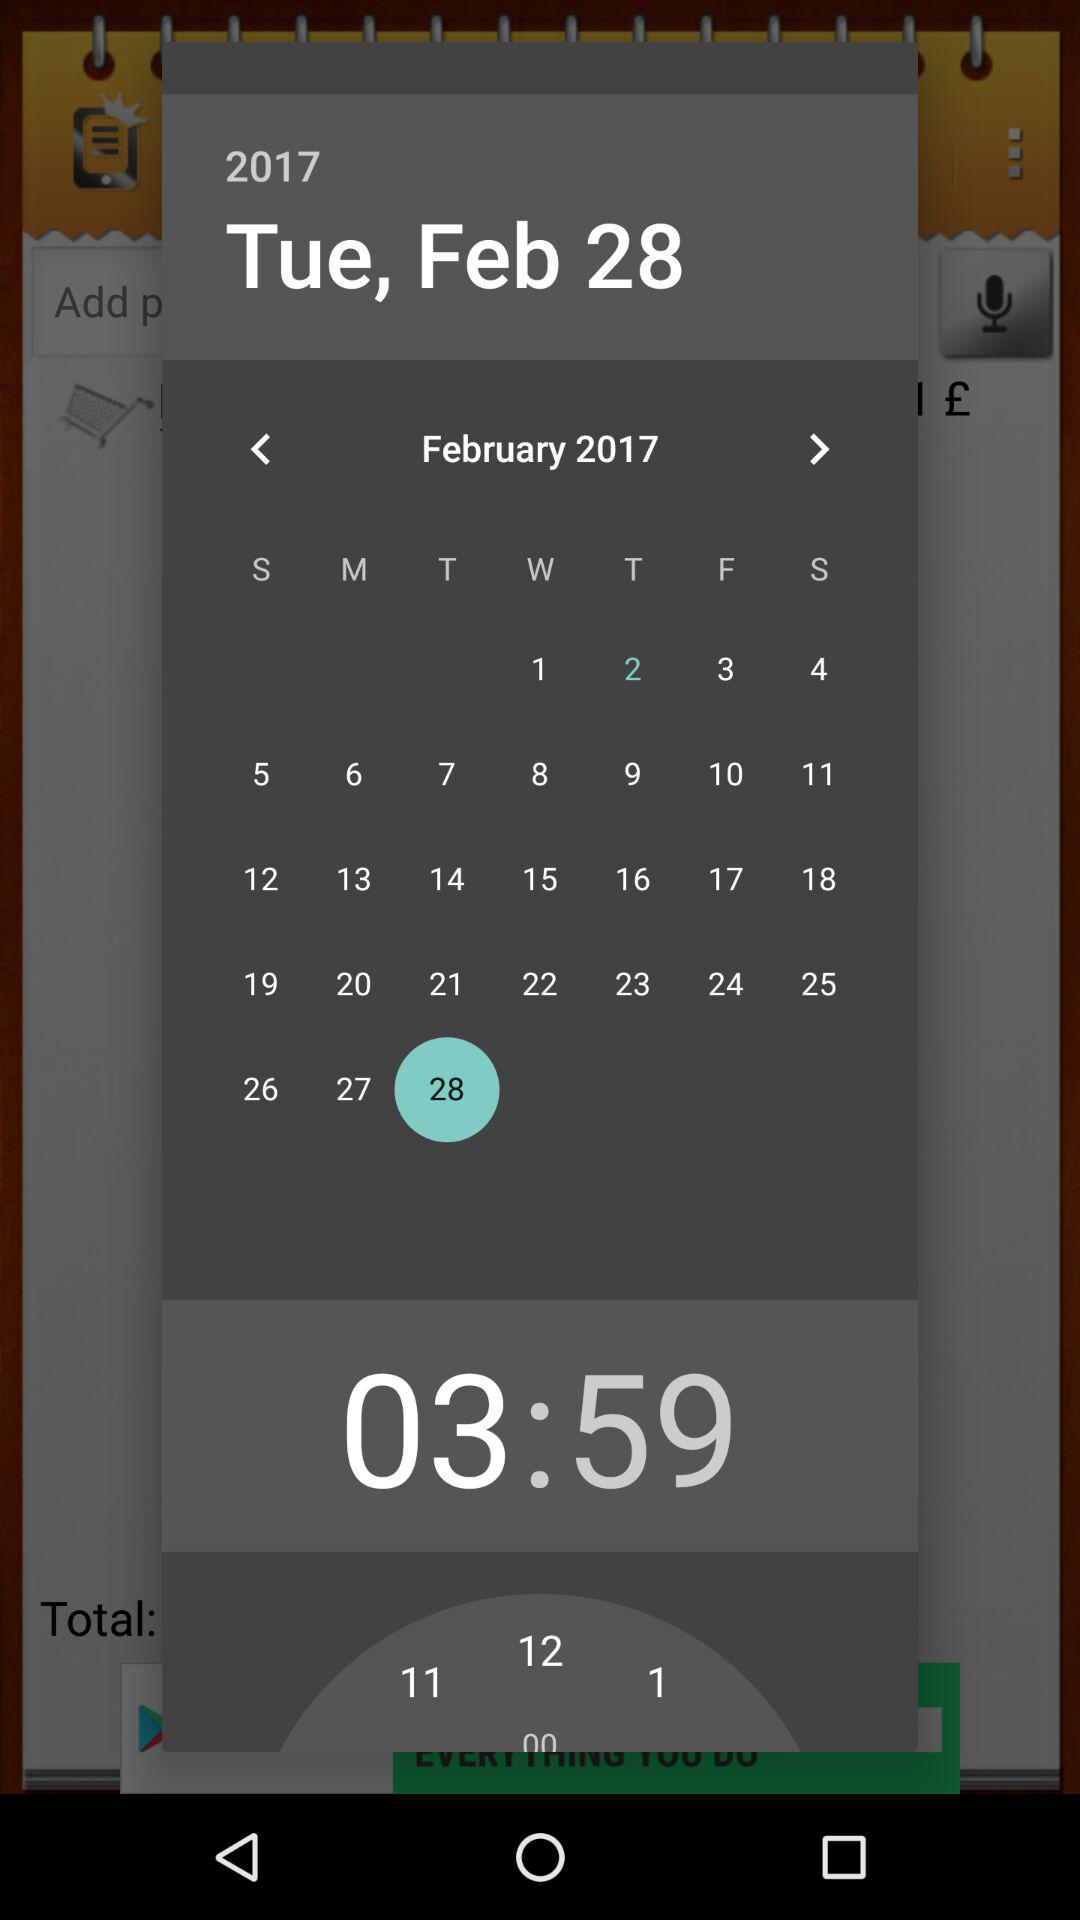What is the time? The time is 03:59. 